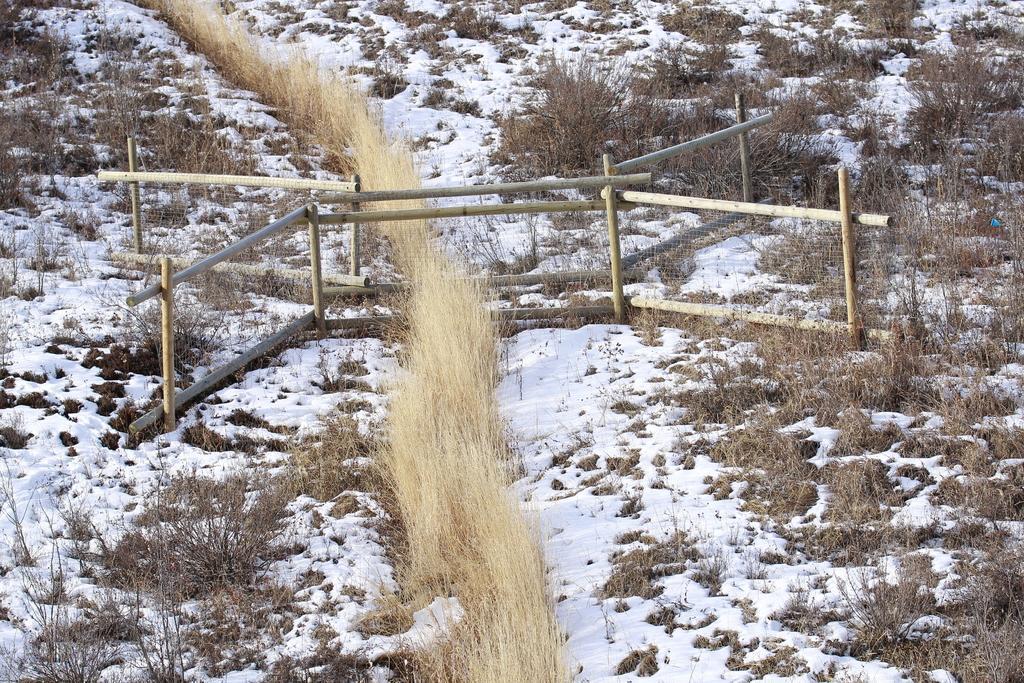Describe this image in one or two sentences. In this image we can see a wooden fencing and snow with dry grass and small plants. 